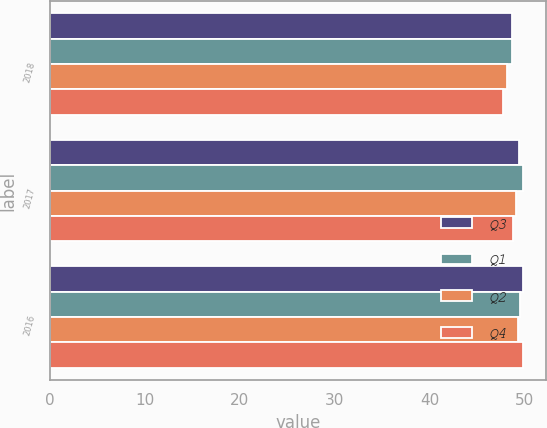Convert chart to OTSL. <chart><loc_0><loc_0><loc_500><loc_500><stacked_bar_chart><ecel><fcel>2018<fcel>2017<fcel>2016<nl><fcel>Q3<fcel>48.7<fcel>49.4<fcel>49.8<nl><fcel>Q1<fcel>48.7<fcel>49.8<fcel>49.5<nl><fcel>Q2<fcel>48.1<fcel>49.1<fcel>49.3<nl><fcel>Q4<fcel>47.7<fcel>48.8<fcel>49.8<nl></chart> 